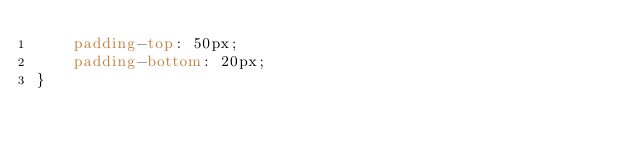<code> <loc_0><loc_0><loc_500><loc_500><_CSS_>    padding-top: 50px;
    padding-bottom: 20px;
}

</code> 